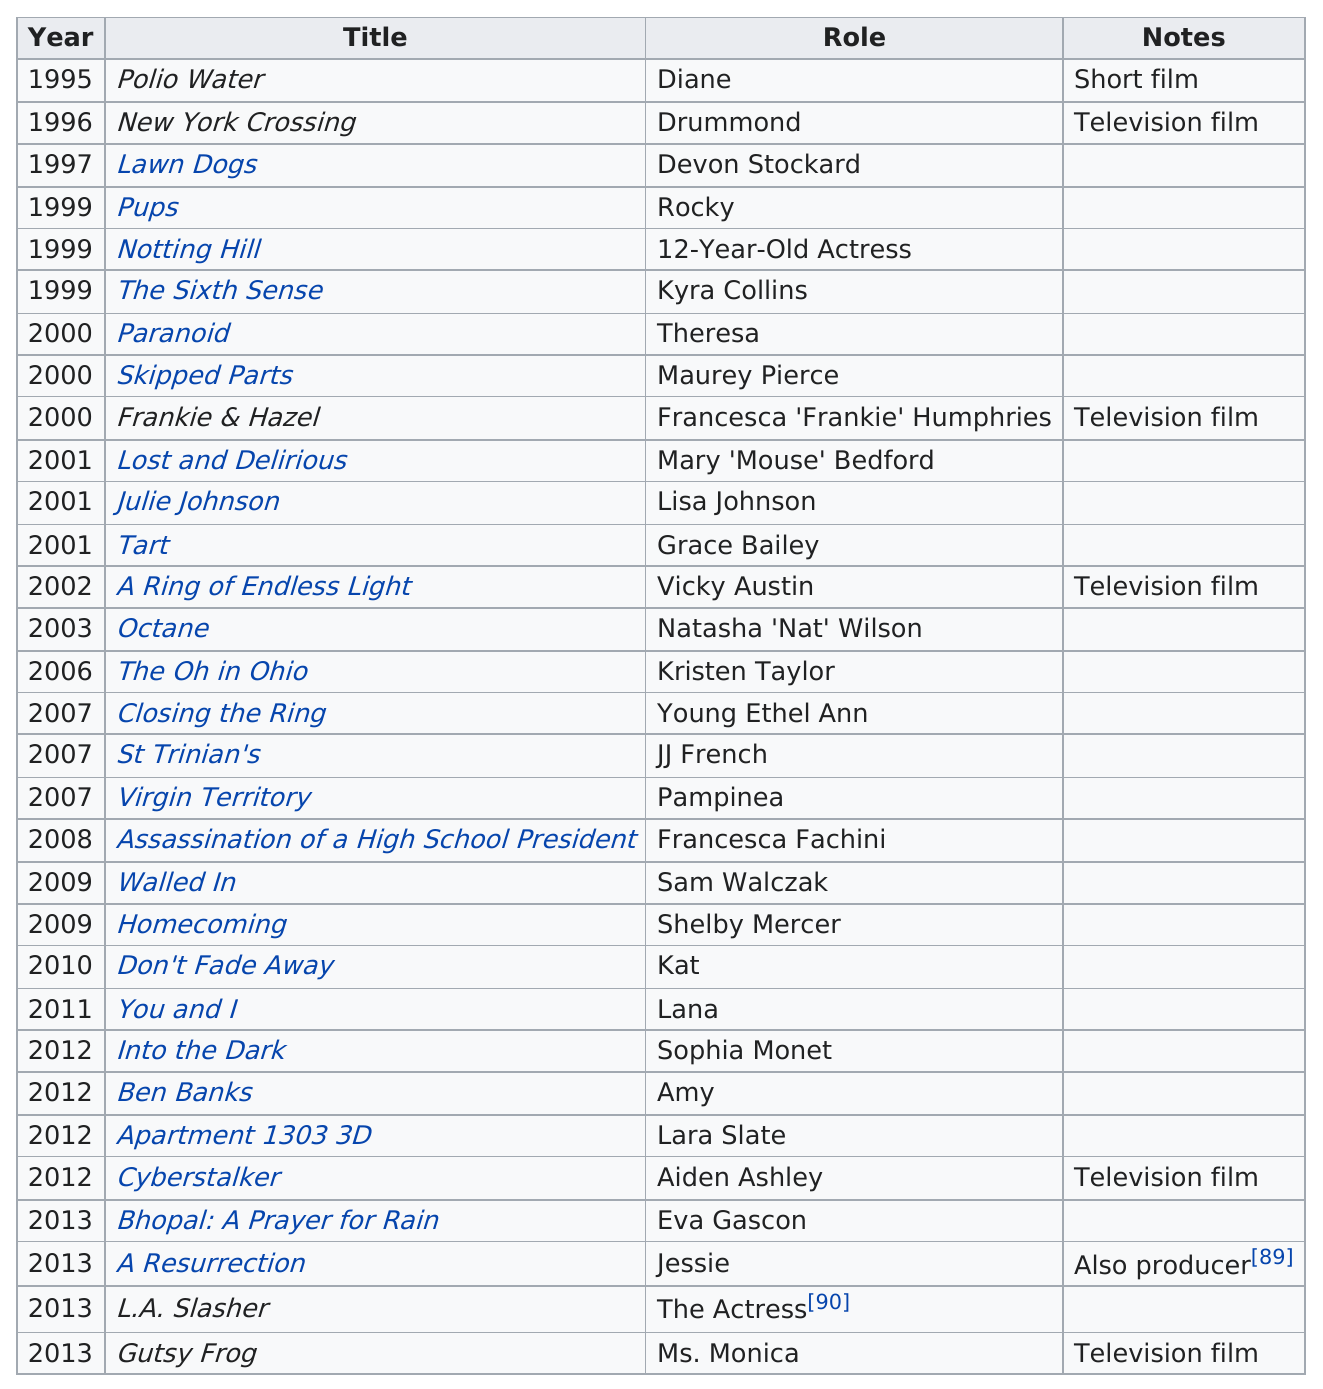Draw attention to some important aspects in this diagram. Mischa Barton played the role of Natasha "Nat" Wilson in the movie "Octane. The movie in question is "The Sixth Sense," in which Mischa Barton portrays the character of Ms. Monica, and the title of the movie is "Gutsy Frog. In the year 1995, Mischa Barton made her debut in the film industry. Barton was also the producer in the movie "A Resurrection. The name of the girl played by Mischa Barton in "The Sixth Sense" is Kyra Collins. 